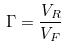Convert formula to latex. <formula><loc_0><loc_0><loc_500><loc_500>\Gamma = \frac { V _ { R } } { V _ { F } }</formula> 